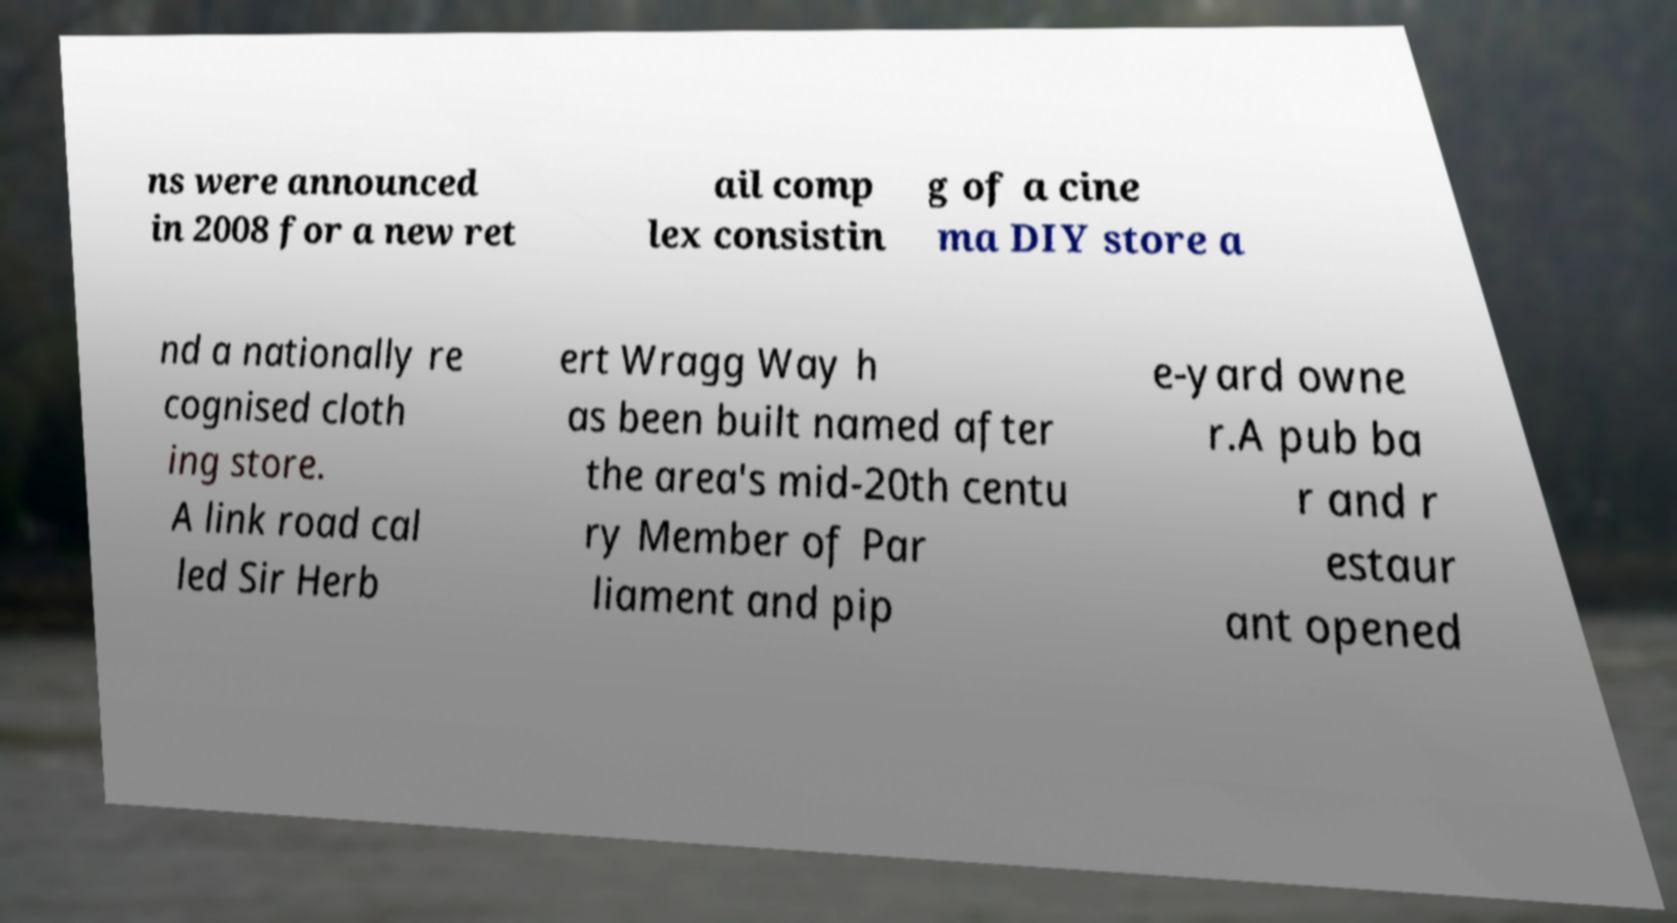I need the written content from this picture converted into text. Can you do that? ns were announced in 2008 for a new ret ail comp lex consistin g of a cine ma DIY store a nd a nationally re cognised cloth ing store. A link road cal led Sir Herb ert Wragg Way h as been built named after the area's mid-20th centu ry Member of Par liament and pip e-yard owne r.A pub ba r and r estaur ant opened 